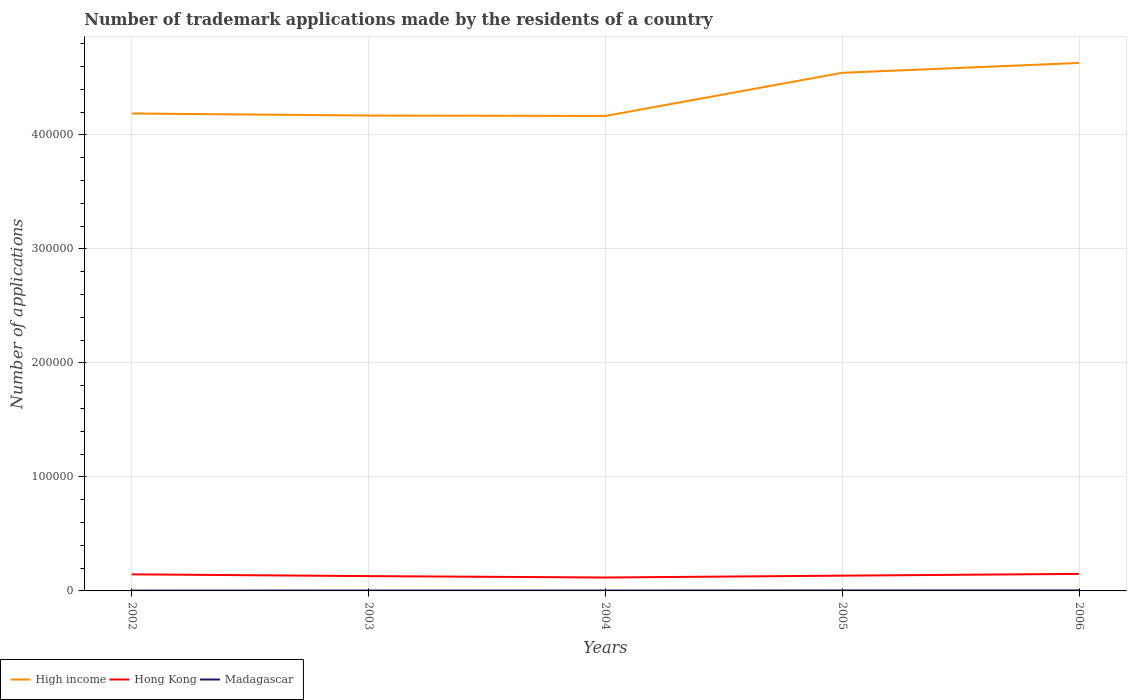Does the line corresponding to Hong Kong intersect with the line corresponding to High income?
Make the answer very short. No. Is the number of lines equal to the number of legend labels?
Provide a short and direct response. Yes. Across all years, what is the maximum number of trademark applications made by the residents in High income?
Make the answer very short. 4.17e+05. In which year was the number of trademark applications made by the residents in Hong Kong maximum?
Your answer should be very brief. 2004. What is the total number of trademark applications made by the residents in High income in the graph?
Your response must be concise. -3.79e+04. What is the difference between the highest and the second highest number of trademark applications made by the residents in High income?
Provide a short and direct response. 4.65e+04. Is the number of trademark applications made by the residents in Madagascar strictly greater than the number of trademark applications made by the residents in High income over the years?
Your answer should be compact. Yes. How many years are there in the graph?
Provide a succinct answer. 5. What is the difference between two consecutive major ticks on the Y-axis?
Provide a succinct answer. 1.00e+05. Are the values on the major ticks of Y-axis written in scientific E-notation?
Give a very brief answer. No. Does the graph contain any zero values?
Make the answer very short. No. Where does the legend appear in the graph?
Keep it short and to the point. Bottom left. How many legend labels are there?
Provide a short and direct response. 3. What is the title of the graph?
Provide a succinct answer. Number of trademark applications made by the residents of a country. Does "Burkina Faso" appear as one of the legend labels in the graph?
Provide a succinct answer. No. What is the label or title of the Y-axis?
Your answer should be compact. Number of applications. What is the Number of applications of High income in 2002?
Provide a short and direct response. 4.19e+05. What is the Number of applications of Hong Kong in 2002?
Give a very brief answer. 1.45e+04. What is the Number of applications in Madagascar in 2002?
Ensure brevity in your answer.  293. What is the Number of applications of High income in 2003?
Your response must be concise. 4.17e+05. What is the Number of applications of Hong Kong in 2003?
Provide a succinct answer. 1.30e+04. What is the Number of applications of Madagascar in 2003?
Provide a succinct answer. 334. What is the Number of applications in High income in 2004?
Your answer should be compact. 4.17e+05. What is the Number of applications of Hong Kong in 2004?
Give a very brief answer. 1.18e+04. What is the Number of applications in Madagascar in 2004?
Provide a succinct answer. 321. What is the Number of applications of High income in 2005?
Ensure brevity in your answer.  4.55e+05. What is the Number of applications in Hong Kong in 2005?
Your answer should be very brief. 1.34e+04. What is the Number of applications in Madagascar in 2005?
Provide a succinct answer. 419. What is the Number of applications of High income in 2006?
Make the answer very short. 4.63e+05. What is the Number of applications in Hong Kong in 2006?
Ensure brevity in your answer.  1.49e+04. What is the Number of applications in Madagascar in 2006?
Keep it short and to the point. 432. Across all years, what is the maximum Number of applications in High income?
Make the answer very short. 4.63e+05. Across all years, what is the maximum Number of applications of Hong Kong?
Give a very brief answer. 1.49e+04. Across all years, what is the maximum Number of applications of Madagascar?
Offer a terse response. 432. Across all years, what is the minimum Number of applications in High income?
Provide a succinct answer. 4.17e+05. Across all years, what is the minimum Number of applications in Hong Kong?
Keep it short and to the point. 1.18e+04. Across all years, what is the minimum Number of applications in Madagascar?
Your answer should be very brief. 293. What is the total Number of applications in High income in the graph?
Your answer should be very brief. 2.17e+06. What is the total Number of applications of Hong Kong in the graph?
Keep it short and to the point. 6.76e+04. What is the total Number of applications in Madagascar in the graph?
Your response must be concise. 1799. What is the difference between the Number of applications of High income in 2002 and that in 2003?
Your answer should be compact. 1808. What is the difference between the Number of applications of Hong Kong in 2002 and that in 2003?
Offer a very short reply. 1548. What is the difference between the Number of applications of Madagascar in 2002 and that in 2003?
Your response must be concise. -41. What is the difference between the Number of applications in High income in 2002 and that in 2004?
Ensure brevity in your answer.  2157. What is the difference between the Number of applications in Hong Kong in 2002 and that in 2004?
Offer a very short reply. 2776. What is the difference between the Number of applications of Madagascar in 2002 and that in 2004?
Offer a terse response. -28. What is the difference between the Number of applications of High income in 2002 and that in 2005?
Offer a very short reply. -3.57e+04. What is the difference between the Number of applications in Hong Kong in 2002 and that in 2005?
Your answer should be very brief. 1153. What is the difference between the Number of applications in Madagascar in 2002 and that in 2005?
Make the answer very short. -126. What is the difference between the Number of applications in High income in 2002 and that in 2006?
Offer a very short reply. -4.43e+04. What is the difference between the Number of applications of Hong Kong in 2002 and that in 2006?
Provide a short and direct response. -393. What is the difference between the Number of applications in Madagascar in 2002 and that in 2006?
Your answer should be very brief. -139. What is the difference between the Number of applications in High income in 2003 and that in 2004?
Provide a short and direct response. 349. What is the difference between the Number of applications in Hong Kong in 2003 and that in 2004?
Provide a succinct answer. 1228. What is the difference between the Number of applications in Madagascar in 2003 and that in 2004?
Make the answer very short. 13. What is the difference between the Number of applications in High income in 2003 and that in 2005?
Your response must be concise. -3.75e+04. What is the difference between the Number of applications in Hong Kong in 2003 and that in 2005?
Provide a succinct answer. -395. What is the difference between the Number of applications of Madagascar in 2003 and that in 2005?
Provide a short and direct response. -85. What is the difference between the Number of applications of High income in 2003 and that in 2006?
Provide a succinct answer. -4.61e+04. What is the difference between the Number of applications in Hong Kong in 2003 and that in 2006?
Provide a short and direct response. -1941. What is the difference between the Number of applications in Madagascar in 2003 and that in 2006?
Provide a succinct answer. -98. What is the difference between the Number of applications in High income in 2004 and that in 2005?
Provide a succinct answer. -3.79e+04. What is the difference between the Number of applications of Hong Kong in 2004 and that in 2005?
Your response must be concise. -1623. What is the difference between the Number of applications of Madagascar in 2004 and that in 2005?
Keep it short and to the point. -98. What is the difference between the Number of applications in High income in 2004 and that in 2006?
Provide a short and direct response. -4.65e+04. What is the difference between the Number of applications of Hong Kong in 2004 and that in 2006?
Provide a short and direct response. -3169. What is the difference between the Number of applications in Madagascar in 2004 and that in 2006?
Keep it short and to the point. -111. What is the difference between the Number of applications in High income in 2005 and that in 2006?
Ensure brevity in your answer.  -8614. What is the difference between the Number of applications in Hong Kong in 2005 and that in 2006?
Keep it short and to the point. -1546. What is the difference between the Number of applications in Madagascar in 2005 and that in 2006?
Your response must be concise. -13. What is the difference between the Number of applications in High income in 2002 and the Number of applications in Hong Kong in 2003?
Your response must be concise. 4.06e+05. What is the difference between the Number of applications in High income in 2002 and the Number of applications in Madagascar in 2003?
Provide a short and direct response. 4.18e+05. What is the difference between the Number of applications in Hong Kong in 2002 and the Number of applications in Madagascar in 2003?
Give a very brief answer. 1.42e+04. What is the difference between the Number of applications in High income in 2002 and the Number of applications in Hong Kong in 2004?
Offer a very short reply. 4.07e+05. What is the difference between the Number of applications of High income in 2002 and the Number of applications of Madagascar in 2004?
Offer a very short reply. 4.18e+05. What is the difference between the Number of applications of Hong Kong in 2002 and the Number of applications of Madagascar in 2004?
Ensure brevity in your answer.  1.42e+04. What is the difference between the Number of applications of High income in 2002 and the Number of applications of Hong Kong in 2005?
Your answer should be very brief. 4.05e+05. What is the difference between the Number of applications in High income in 2002 and the Number of applications in Madagascar in 2005?
Your response must be concise. 4.18e+05. What is the difference between the Number of applications of Hong Kong in 2002 and the Number of applications of Madagascar in 2005?
Offer a terse response. 1.41e+04. What is the difference between the Number of applications in High income in 2002 and the Number of applications in Hong Kong in 2006?
Your answer should be very brief. 4.04e+05. What is the difference between the Number of applications of High income in 2002 and the Number of applications of Madagascar in 2006?
Provide a short and direct response. 4.18e+05. What is the difference between the Number of applications in Hong Kong in 2002 and the Number of applications in Madagascar in 2006?
Provide a succinct answer. 1.41e+04. What is the difference between the Number of applications of High income in 2003 and the Number of applications of Hong Kong in 2004?
Keep it short and to the point. 4.05e+05. What is the difference between the Number of applications in High income in 2003 and the Number of applications in Madagascar in 2004?
Keep it short and to the point. 4.17e+05. What is the difference between the Number of applications of Hong Kong in 2003 and the Number of applications of Madagascar in 2004?
Provide a short and direct response. 1.27e+04. What is the difference between the Number of applications in High income in 2003 and the Number of applications in Hong Kong in 2005?
Keep it short and to the point. 4.04e+05. What is the difference between the Number of applications of High income in 2003 and the Number of applications of Madagascar in 2005?
Give a very brief answer. 4.17e+05. What is the difference between the Number of applications of Hong Kong in 2003 and the Number of applications of Madagascar in 2005?
Keep it short and to the point. 1.26e+04. What is the difference between the Number of applications in High income in 2003 and the Number of applications in Hong Kong in 2006?
Your response must be concise. 4.02e+05. What is the difference between the Number of applications of High income in 2003 and the Number of applications of Madagascar in 2006?
Your answer should be compact. 4.17e+05. What is the difference between the Number of applications of Hong Kong in 2003 and the Number of applications of Madagascar in 2006?
Your answer should be very brief. 1.26e+04. What is the difference between the Number of applications of High income in 2004 and the Number of applications of Hong Kong in 2005?
Provide a succinct answer. 4.03e+05. What is the difference between the Number of applications in High income in 2004 and the Number of applications in Madagascar in 2005?
Offer a very short reply. 4.16e+05. What is the difference between the Number of applications of Hong Kong in 2004 and the Number of applications of Madagascar in 2005?
Make the answer very short. 1.13e+04. What is the difference between the Number of applications of High income in 2004 and the Number of applications of Hong Kong in 2006?
Your answer should be compact. 4.02e+05. What is the difference between the Number of applications of High income in 2004 and the Number of applications of Madagascar in 2006?
Offer a very short reply. 4.16e+05. What is the difference between the Number of applications of Hong Kong in 2004 and the Number of applications of Madagascar in 2006?
Ensure brevity in your answer.  1.13e+04. What is the difference between the Number of applications of High income in 2005 and the Number of applications of Hong Kong in 2006?
Your answer should be compact. 4.40e+05. What is the difference between the Number of applications of High income in 2005 and the Number of applications of Madagascar in 2006?
Give a very brief answer. 4.54e+05. What is the difference between the Number of applications in Hong Kong in 2005 and the Number of applications in Madagascar in 2006?
Your response must be concise. 1.30e+04. What is the average Number of applications in High income per year?
Keep it short and to the point. 4.34e+05. What is the average Number of applications in Hong Kong per year?
Ensure brevity in your answer.  1.35e+04. What is the average Number of applications in Madagascar per year?
Your response must be concise. 359.8. In the year 2002, what is the difference between the Number of applications of High income and Number of applications of Hong Kong?
Offer a terse response. 4.04e+05. In the year 2002, what is the difference between the Number of applications in High income and Number of applications in Madagascar?
Provide a succinct answer. 4.19e+05. In the year 2002, what is the difference between the Number of applications of Hong Kong and Number of applications of Madagascar?
Provide a short and direct response. 1.42e+04. In the year 2003, what is the difference between the Number of applications in High income and Number of applications in Hong Kong?
Provide a short and direct response. 4.04e+05. In the year 2003, what is the difference between the Number of applications of High income and Number of applications of Madagascar?
Give a very brief answer. 4.17e+05. In the year 2003, what is the difference between the Number of applications in Hong Kong and Number of applications in Madagascar?
Keep it short and to the point. 1.27e+04. In the year 2004, what is the difference between the Number of applications in High income and Number of applications in Hong Kong?
Keep it short and to the point. 4.05e+05. In the year 2004, what is the difference between the Number of applications of High income and Number of applications of Madagascar?
Provide a succinct answer. 4.16e+05. In the year 2004, what is the difference between the Number of applications in Hong Kong and Number of applications in Madagascar?
Ensure brevity in your answer.  1.14e+04. In the year 2005, what is the difference between the Number of applications in High income and Number of applications in Hong Kong?
Provide a succinct answer. 4.41e+05. In the year 2005, what is the difference between the Number of applications in High income and Number of applications in Madagascar?
Make the answer very short. 4.54e+05. In the year 2005, what is the difference between the Number of applications of Hong Kong and Number of applications of Madagascar?
Offer a terse response. 1.30e+04. In the year 2006, what is the difference between the Number of applications of High income and Number of applications of Hong Kong?
Your answer should be very brief. 4.48e+05. In the year 2006, what is the difference between the Number of applications in High income and Number of applications in Madagascar?
Make the answer very short. 4.63e+05. In the year 2006, what is the difference between the Number of applications in Hong Kong and Number of applications in Madagascar?
Make the answer very short. 1.45e+04. What is the ratio of the Number of applications in High income in 2002 to that in 2003?
Offer a terse response. 1. What is the ratio of the Number of applications of Hong Kong in 2002 to that in 2003?
Your answer should be very brief. 1.12. What is the ratio of the Number of applications in Madagascar in 2002 to that in 2003?
Your response must be concise. 0.88. What is the ratio of the Number of applications in Hong Kong in 2002 to that in 2004?
Provide a short and direct response. 1.24. What is the ratio of the Number of applications of Madagascar in 2002 to that in 2004?
Provide a short and direct response. 0.91. What is the ratio of the Number of applications in High income in 2002 to that in 2005?
Your response must be concise. 0.92. What is the ratio of the Number of applications of Hong Kong in 2002 to that in 2005?
Provide a short and direct response. 1.09. What is the ratio of the Number of applications of Madagascar in 2002 to that in 2005?
Offer a very short reply. 0.7. What is the ratio of the Number of applications of High income in 2002 to that in 2006?
Provide a short and direct response. 0.9. What is the ratio of the Number of applications in Hong Kong in 2002 to that in 2006?
Provide a short and direct response. 0.97. What is the ratio of the Number of applications in Madagascar in 2002 to that in 2006?
Your answer should be compact. 0.68. What is the ratio of the Number of applications of High income in 2003 to that in 2004?
Give a very brief answer. 1. What is the ratio of the Number of applications of Hong Kong in 2003 to that in 2004?
Offer a terse response. 1.1. What is the ratio of the Number of applications of Madagascar in 2003 to that in 2004?
Give a very brief answer. 1.04. What is the ratio of the Number of applications of High income in 2003 to that in 2005?
Give a very brief answer. 0.92. What is the ratio of the Number of applications in Hong Kong in 2003 to that in 2005?
Ensure brevity in your answer.  0.97. What is the ratio of the Number of applications in Madagascar in 2003 to that in 2005?
Keep it short and to the point. 0.8. What is the ratio of the Number of applications in High income in 2003 to that in 2006?
Your answer should be very brief. 0.9. What is the ratio of the Number of applications in Hong Kong in 2003 to that in 2006?
Your answer should be very brief. 0.87. What is the ratio of the Number of applications of Madagascar in 2003 to that in 2006?
Give a very brief answer. 0.77. What is the ratio of the Number of applications of Hong Kong in 2004 to that in 2005?
Your answer should be very brief. 0.88. What is the ratio of the Number of applications in Madagascar in 2004 to that in 2005?
Offer a very short reply. 0.77. What is the ratio of the Number of applications in High income in 2004 to that in 2006?
Provide a short and direct response. 0.9. What is the ratio of the Number of applications of Hong Kong in 2004 to that in 2006?
Offer a very short reply. 0.79. What is the ratio of the Number of applications in Madagascar in 2004 to that in 2006?
Provide a succinct answer. 0.74. What is the ratio of the Number of applications in High income in 2005 to that in 2006?
Offer a terse response. 0.98. What is the ratio of the Number of applications of Hong Kong in 2005 to that in 2006?
Your answer should be compact. 0.9. What is the ratio of the Number of applications of Madagascar in 2005 to that in 2006?
Offer a very short reply. 0.97. What is the difference between the highest and the second highest Number of applications in High income?
Give a very brief answer. 8614. What is the difference between the highest and the second highest Number of applications in Hong Kong?
Your answer should be very brief. 393. What is the difference between the highest and the second highest Number of applications of Madagascar?
Ensure brevity in your answer.  13. What is the difference between the highest and the lowest Number of applications in High income?
Keep it short and to the point. 4.65e+04. What is the difference between the highest and the lowest Number of applications in Hong Kong?
Ensure brevity in your answer.  3169. What is the difference between the highest and the lowest Number of applications of Madagascar?
Your response must be concise. 139. 